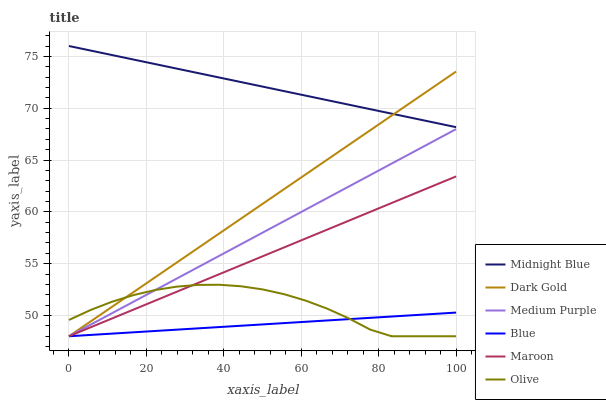Does Blue have the minimum area under the curve?
Answer yes or no. Yes. Does Midnight Blue have the maximum area under the curve?
Answer yes or no. Yes. Does Dark Gold have the minimum area under the curve?
Answer yes or no. No. Does Dark Gold have the maximum area under the curve?
Answer yes or no. No. Is Blue the smoothest?
Answer yes or no. Yes. Is Olive the roughest?
Answer yes or no. Yes. Is Midnight Blue the smoothest?
Answer yes or no. No. Is Midnight Blue the roughest?
Answer yes or no. No. Does Blue have the lowest value?
Answer yes or no. Yes. Does Midnight Blue have the lowest value?
Answer yes or no. No. Does Midnight Blue have the highest value?
Answer yes or no. Yes. Does Dark Gold have the highest value?
Answer yes or no. No. Is Olive less than Midnight Blue?
Answer yes or no. Yes. Is Midnight Blue greater than Medium Purple?
Answer yes or no. Yes. Does Dark Gold intersect Maroon?
Answer yes or no. Yes. Is Dark Gold less than Maroon?
Answer yes or no. No. Is Dark Gold greater than Maroon?
Answer yes or no. No. Does Olive intersect Midnight Blue?
Answer yes or no. No. 